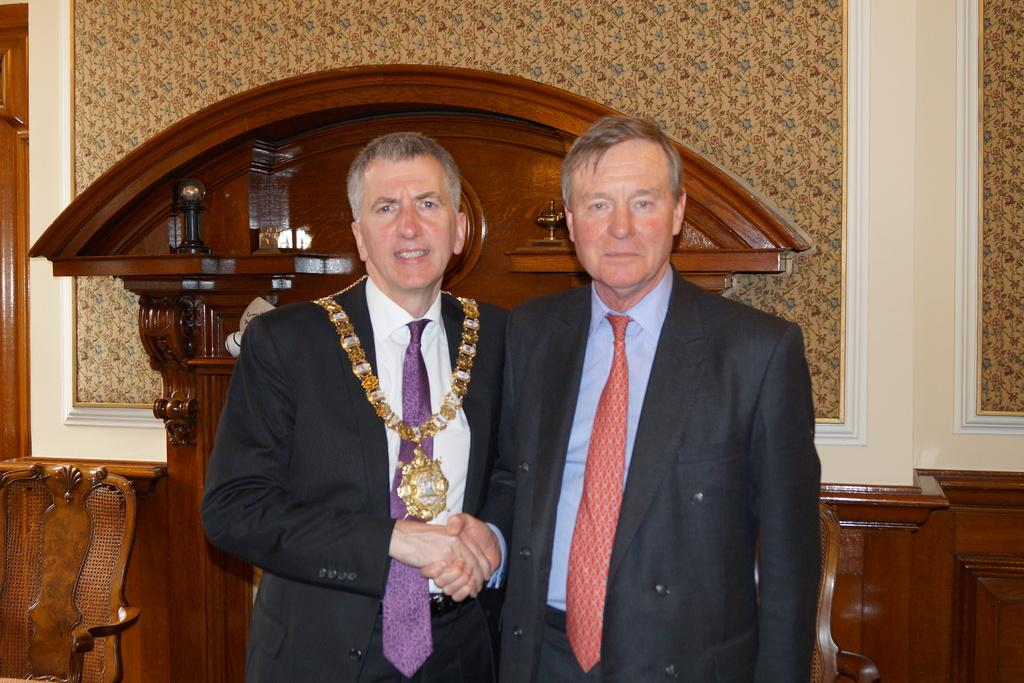How many people are present in the image? There are two men in the image. What can be seen in the background of the image? There is a wall and a cupboard in the background of the image. What type of game are the men playing in the image? There is no game being played in the image; it only shows two men and a background with a wall and a cupboard. 